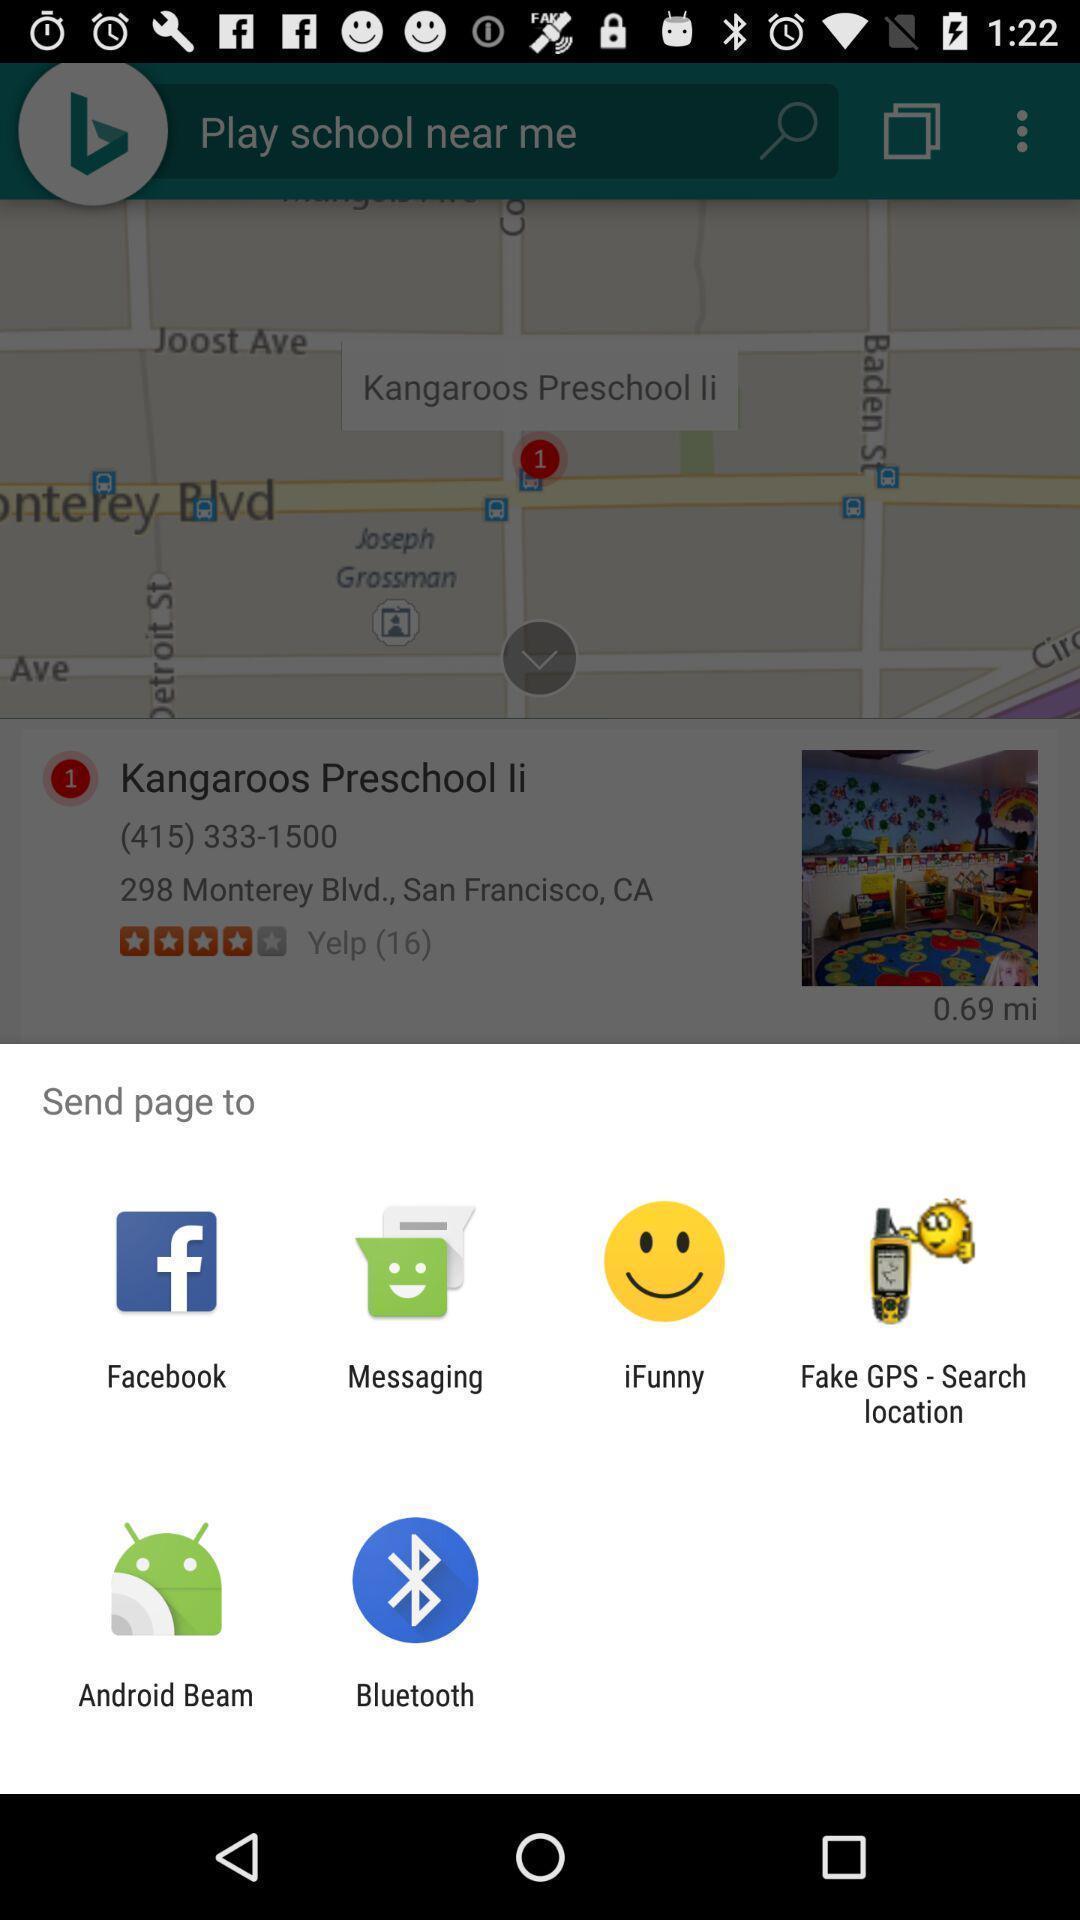Tell me about the visual elements in this screen capture. Pop-up shows few app icons. 